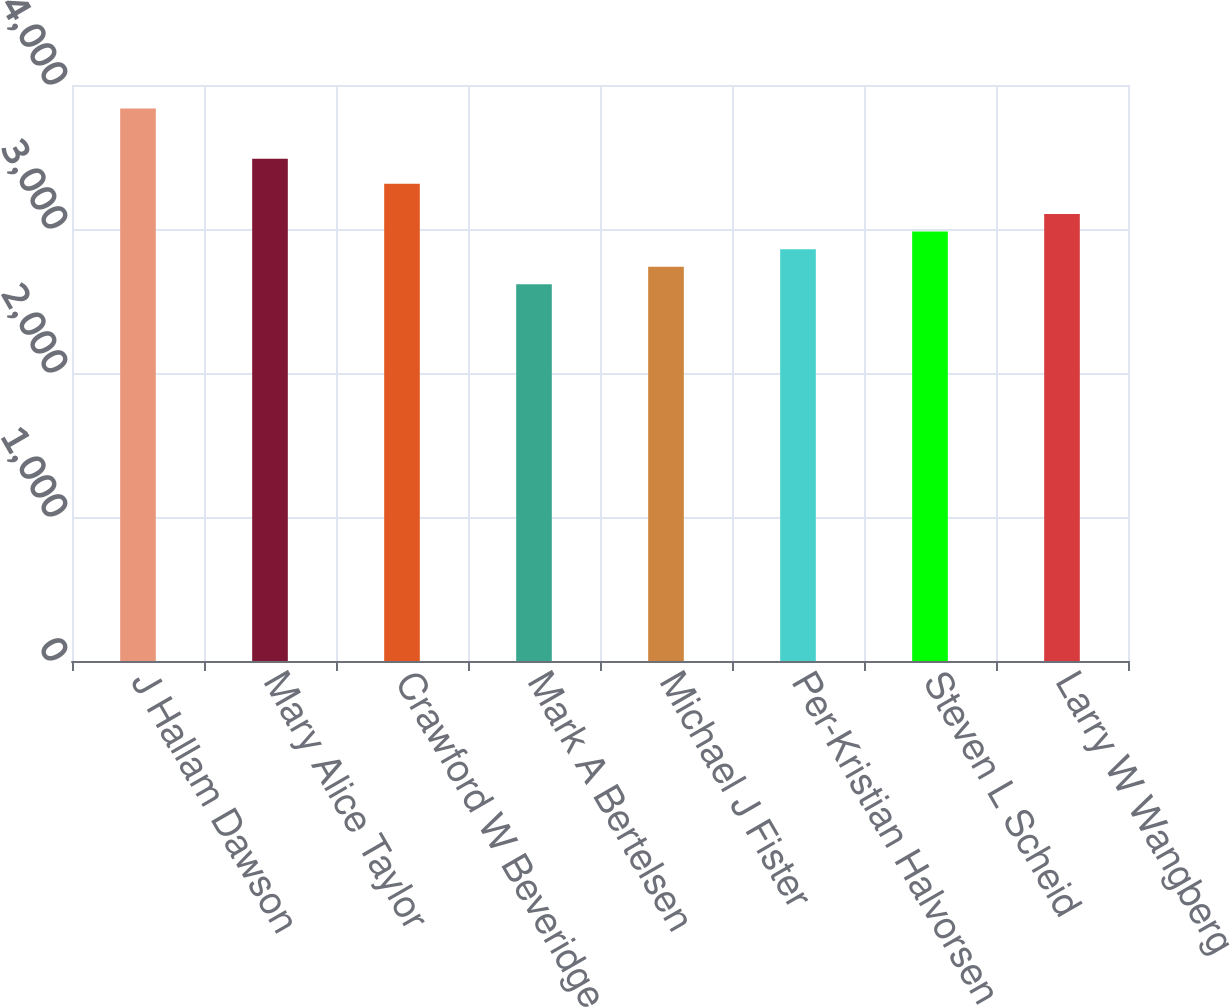Convert chart. <chart><loc_0><loc_0><loc_500><loc_500><bar_chart><fcel>J Hallam Dawson<fcel>Mary Alice Taylor<fcel>Crawford W Beveridge<fcel>Mark A Bertelsen<fcel>Michael J Fister<fcel>Per-Kristian Halvorsen<fcel>Steven L Scheid<fcel>Larry W Wangberg<nl><fcel>3837<fcel>3488<fcel>3314<fcel>2616<fcel>2738.1<fcel>2860.2<fcel>2982.3<fcel>3104.4<nl></chart> 